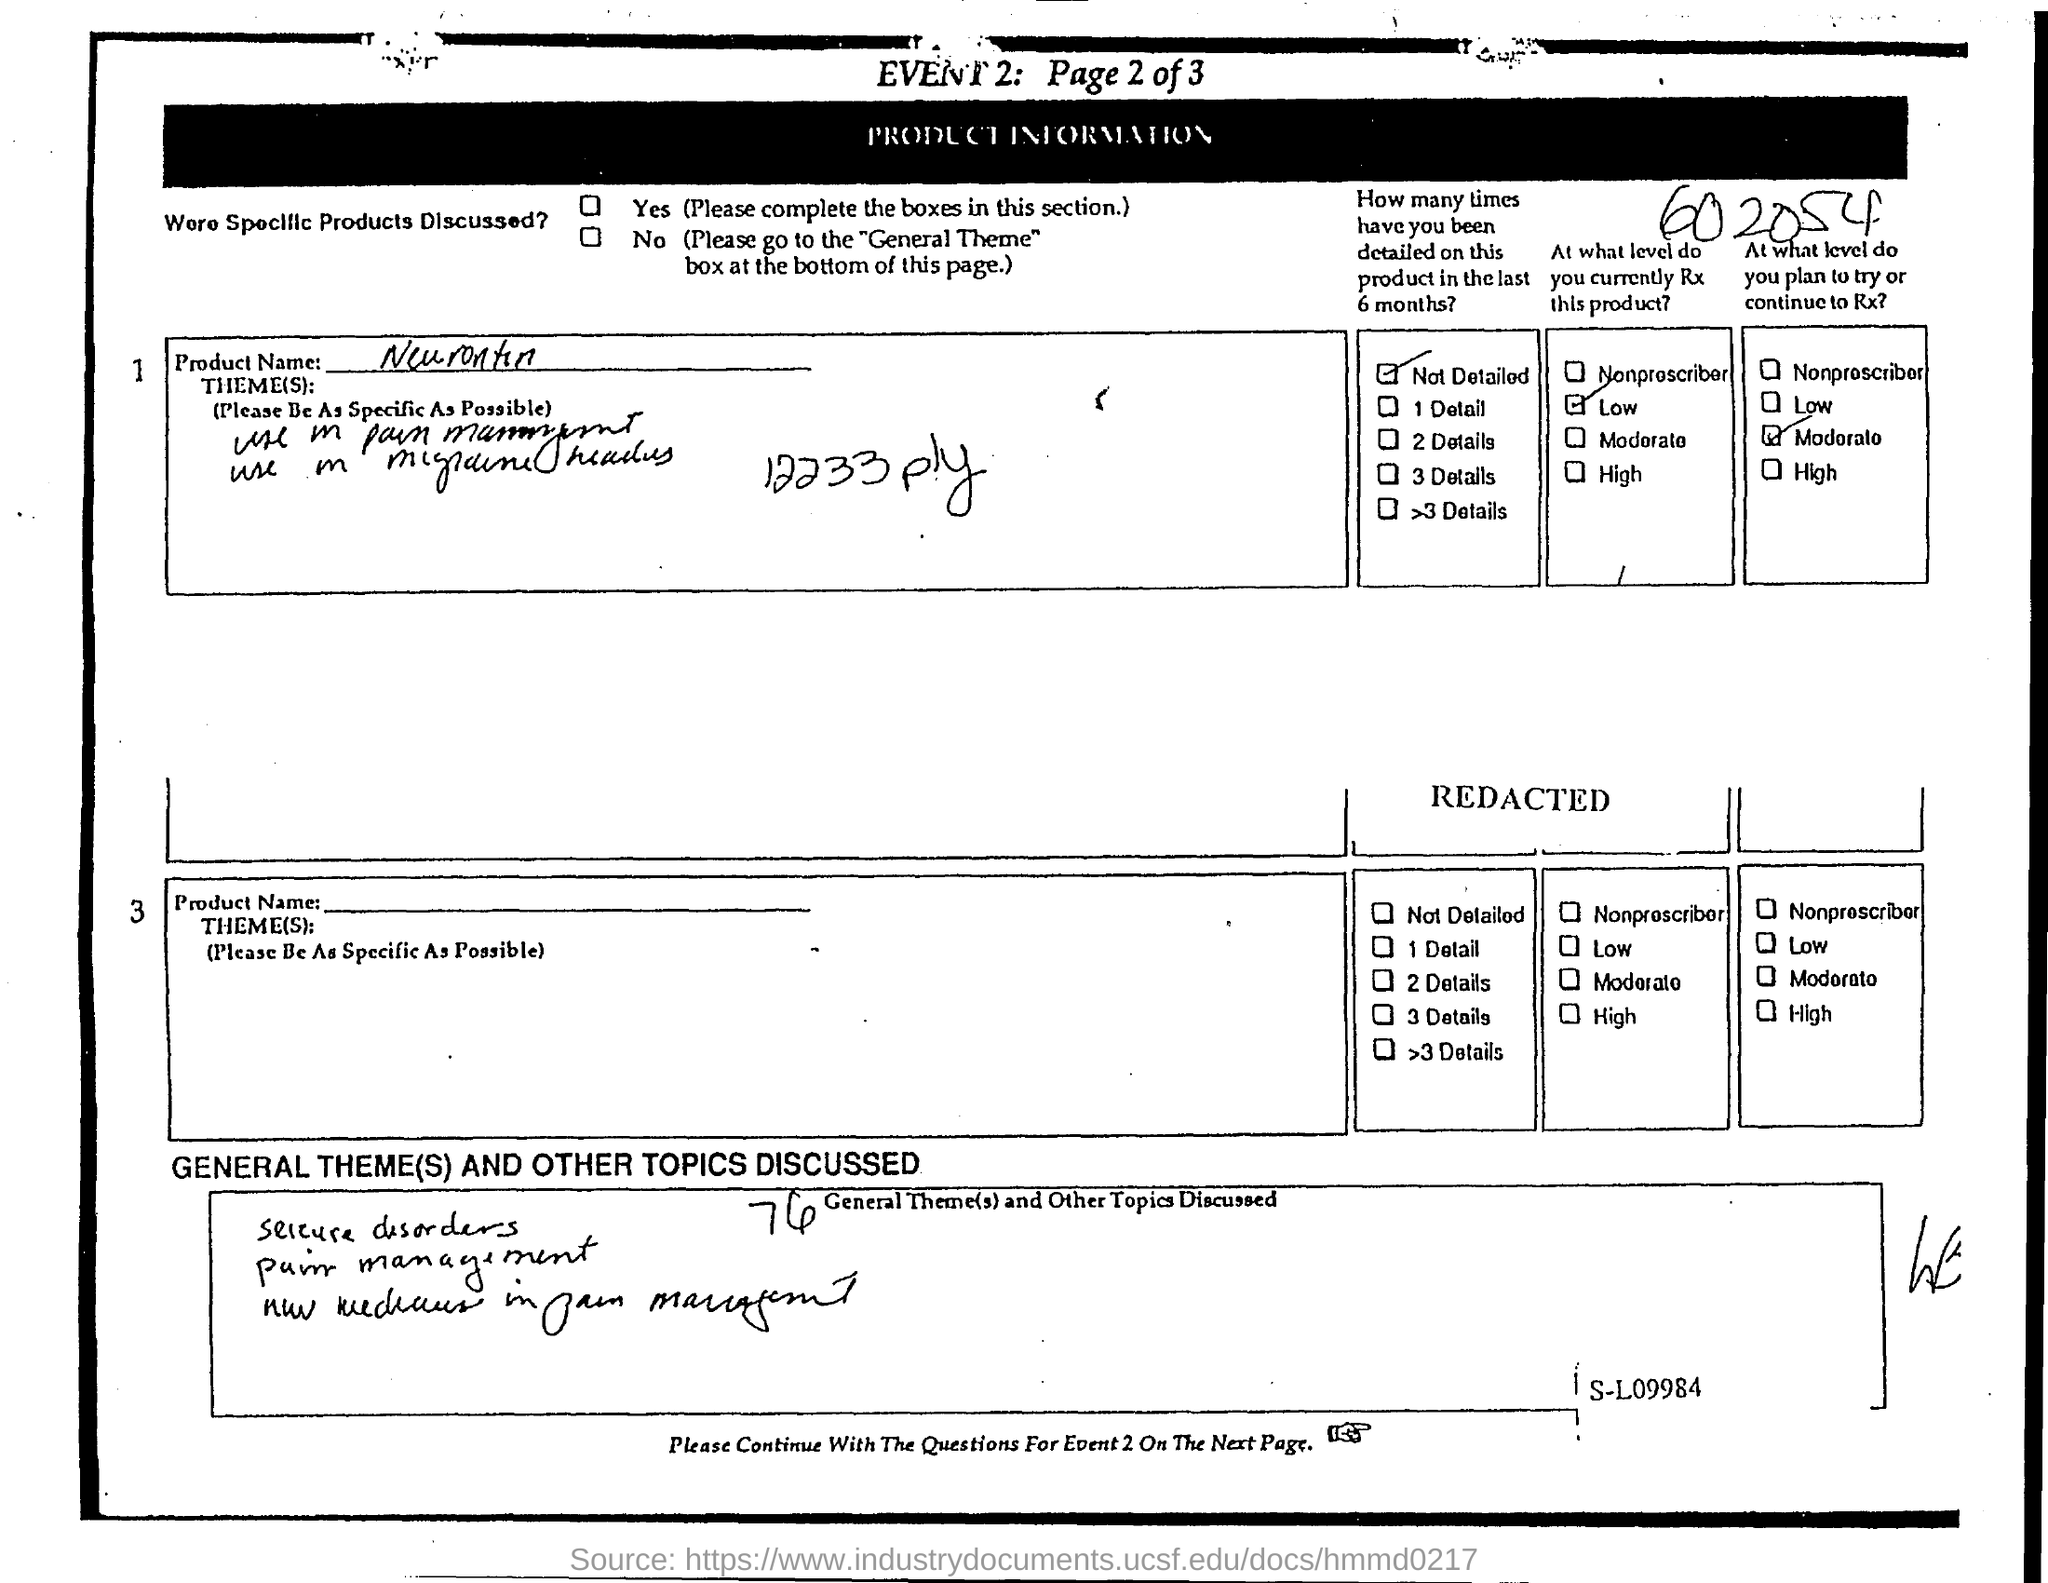What is the Title of the document?
Offer a very short reply. Event 2: page 2 of 3. What is the Product name?
Keep it short and to the point. Neurontin. 